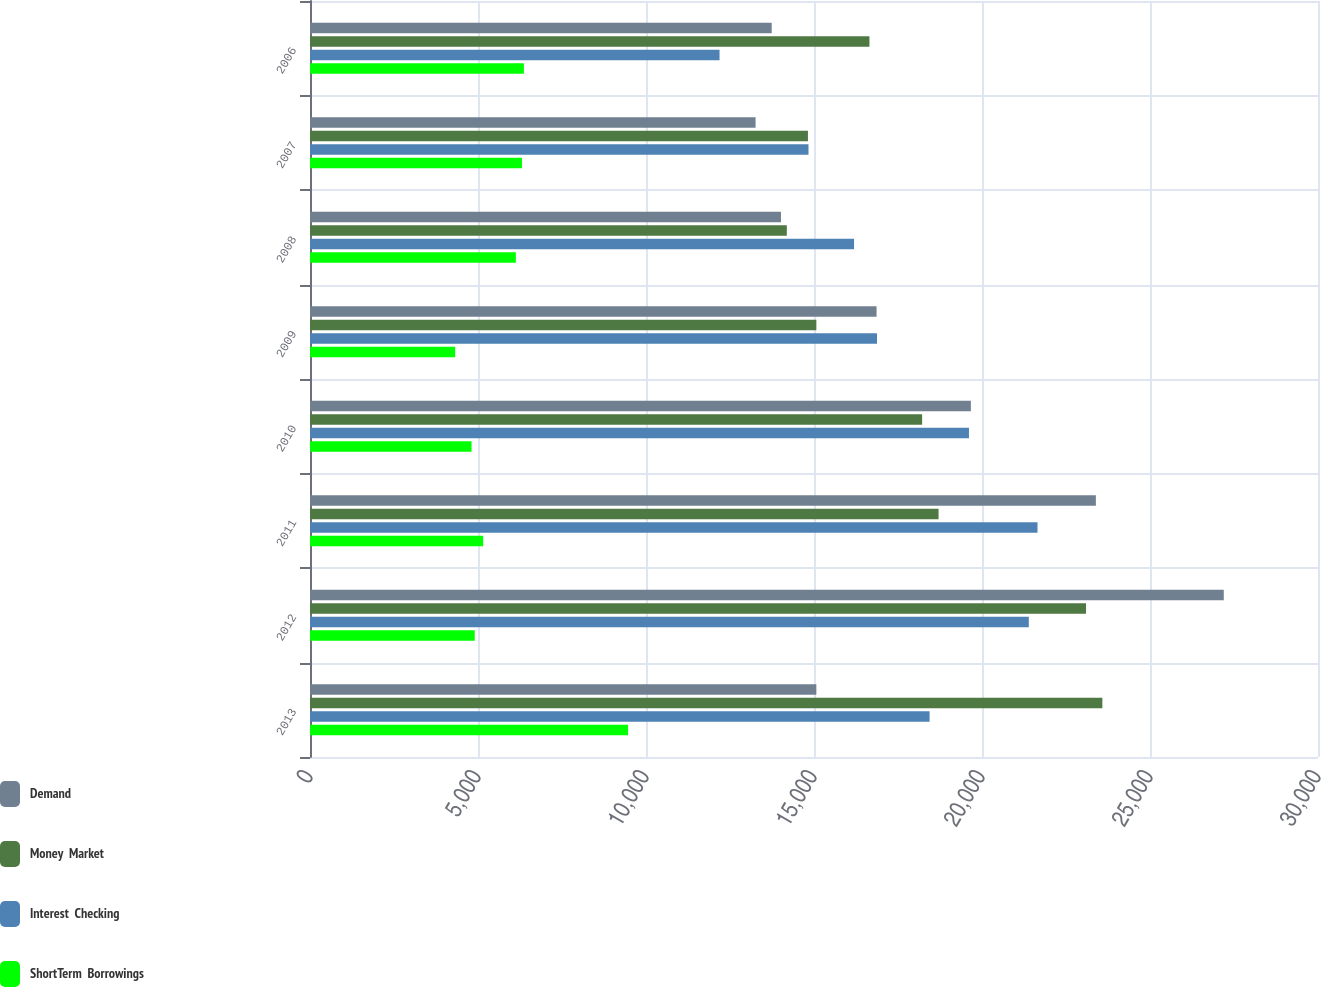Convert chart. <chart><loc_0><loc_0><loc_500><loc_500><stacked_bar_chart><ecel><fcel>2013<fcel>2012<fcel>2011<fcel>2010<fcel>2009<fcel>2008<fcel>2007<fcel>2006<nl><fcel>Demand<fcel>15070<fcel>27196<fcel>23389<fcel>19669<fcel>16862<fcel>14017<fcel>13261<fcel>13741<nl><fcel>Money  Market<fcel>23582<fcel>23096<fcel>18707<fcel>18218<fcel>15070<fcel>14191<fcel>14820<fcel>16650<nl><fcel>Interest  Checking<fcel>18440<fcel>21393<fcel>21652<fcel>19612<fcel>16875<fcel>16192<fcel>14836<fcel>12189<nl><fcel>ShortTerm  Borrowings<fcel>9467<fcel>4903<fcel>5154<fcel>4808<fcel>4320<fcel>6127<fcel>6308<fcel>6366<nl></chart> 